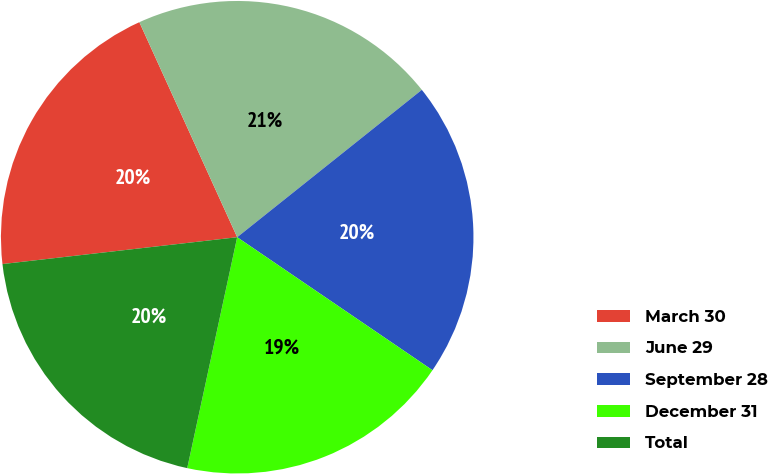<chart> <loc_0><loc_0><loc_500><loc_500><pie_chart><fcel>March 30<fcel>June 29<fcel>September 28<fcel>December 31<fcel>Total<nl><fcel>20.02%<fcel>21.08%<fcel>20.24%<fcel>18.88%<fcel>19.8%<nl></chart> 